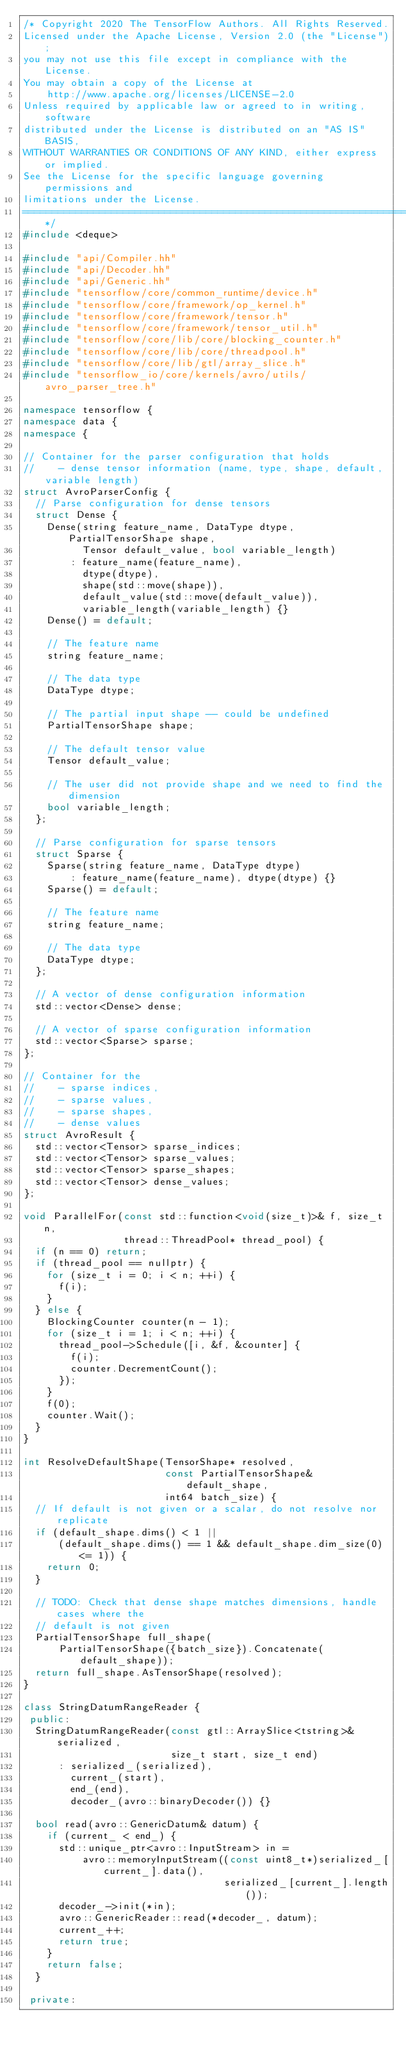Convert code to text. <code><loc_0><loc_0><loc_500><loc_500><_C++_>/* Copyright 2020 The TensorFlow Authors. All Rights Reserved.
Licensed under the Apache License, Version 2.0 (the "License");
you may not use this file except in compliance with the License.
You may obtain a copy of the License at
    http://www.apache.org/licenses/LICENSE-2.0
Unless required by applicable law or agreed to in writing, software
distributed under the License is distributed on an "AS IS" BASIS,
WITHOUT WARRANTIES OR CONDITIONS OF ANY KIND, either express or implied.
See the License for the specific language governing permissions and
limitations under the License.
==============================================================================*/
#include <deque>

#include "api/Compiler.hh"
#include "api/Decoder.hh"
#include "api/Generic.hh"
#include "tensorflow/core/common_runtime/device.h"
#include "tensorflow/core/framework/op_kernel.h"
#include "tensorflow/core/framework/tensor.h"
#include "tensorflow/core/framework/tensor_util.h"
#include "tensorflow/core/lib/core/blocking_counter.h"
#include "tensorflow/core/lib/core/threadpool.h"
#include "tensorflow/core/lib/gtl/array_slice.h"
#include "tensorflow_io/core/kernels/avro/utils/avro_parser_tree.h"

namespace tensorflow {
namespace data {
namespace {

// Container for the parser configuration that holds
//    - dense tensor information (name, type, shape, default, variable length)
struct AvroParserConfig {
  // Parse configuration for dense tensors
  struct Dense {
    Dense(string feature_name, DataType dtype, PartialTensorShape shape,
          Tensor default_value, bool variable_length)
        : feature_name(feature_name),
          dtype(dtype),
          shape(std::move(shape)),
          default_value(std::move(default_value)),
          variable_length(variable_length) {}
    Dense() = default;

    // The feature name
    string feature_name;

    // The data type
    DataType dtype;

    // The partial input shape -- could be undefined
    PartialTensorShape shape;

    // The default tensor value
    Tensor default_value;

    // The user did not provide shape and we need to find the dimension
    bool variable_length;
  };

  // Parse configuration for sparse tensors
  struct Sparse {
    Sparse(string feature_name, DataType dtype)
        : feature_name(feature_name), dtype(dtype) {}
    Sparse() = default;

    // The feature name
    string feature_name;

    // The data type
    DataType dtype;
  };

  // A vector of dense configuration information
  std::vector<Dense> dense;

  // A vector of sparse configuration information
  std::vector<Sparse> sparse;
};

// Container for the
//    - sparse indices,
//    - sparse values,
//    - sparse shapes,
//    - dense values
struct AvroResult {
  std::vector<Tensor> sparse_indices;
  std::vector<Tensor> sparse_values;
  std::vector<Tensor> sparse_shapes;
  std::vector<Tensor> dense_values;
};

void ParallelFor(const std::function<void(size_t)>& f, size_t n,
                 thread::ThreadPool* thread_pool) {
  if (n == 0) return;
  if (thread_pool == nullptr) {
    for (size_t i = 0; i < n; ++i) {
      f(i);
    }
  } else {
    BlockingCounter counter(n - 1);
    for (size_t i = 1; i < n; ++i) {
      thread_pool->Schedule([i, &f, &counter] {
        f(i);
        counter.DecrementCount();
      });
    }
    f(0);
    counter.Wait();
  }
}

int ResolveDefaultShape(TensorShape* resolved,
                        const PartialTensorShape& default_shape,
                        int64 batch_size) {
  // If default is not given or a scalar, do not resolve nor replicate
  if (default_shape.dims() < 1 ||
      (default_shape.dims() == 1 && default_shape.dim_size(0) <= 1)) {
    return 0;
  }

  // TODO: Check that dense shape matches dimensions, handle cases where the
  // default is not given
  PartialTensorShape full_shape(
      PartialTensorShape({batch_size}).Concatenate(default_shape));
  return full_shape.AsTensorShape(resolved);
}

class StringDatumRangeReader {
 public:
  StringDatumRangeReader(const gtl::ArraySlice<tstring>& serialized,
                         size_t start, size_t end)
      : serialized_(serialized),
        current_(start),
        end_(end),
        decoder_(avro::binaryDecoder()) {}

  bool read(avro::GenericDatum& datum) {
    if (current_ < end_) {
      std::unique_ptr<avro::InputStream> in =
          avro::memoryInputStream((const uint8_t*)serialized_[current_].data(),
                                  serialized_[current_].length());
      decoder_->init(*in);
      avro::GenericReader::read(*decoder_, datum);
      current_++;
      return true;
    }
    return false;
  }

 private:</code> 